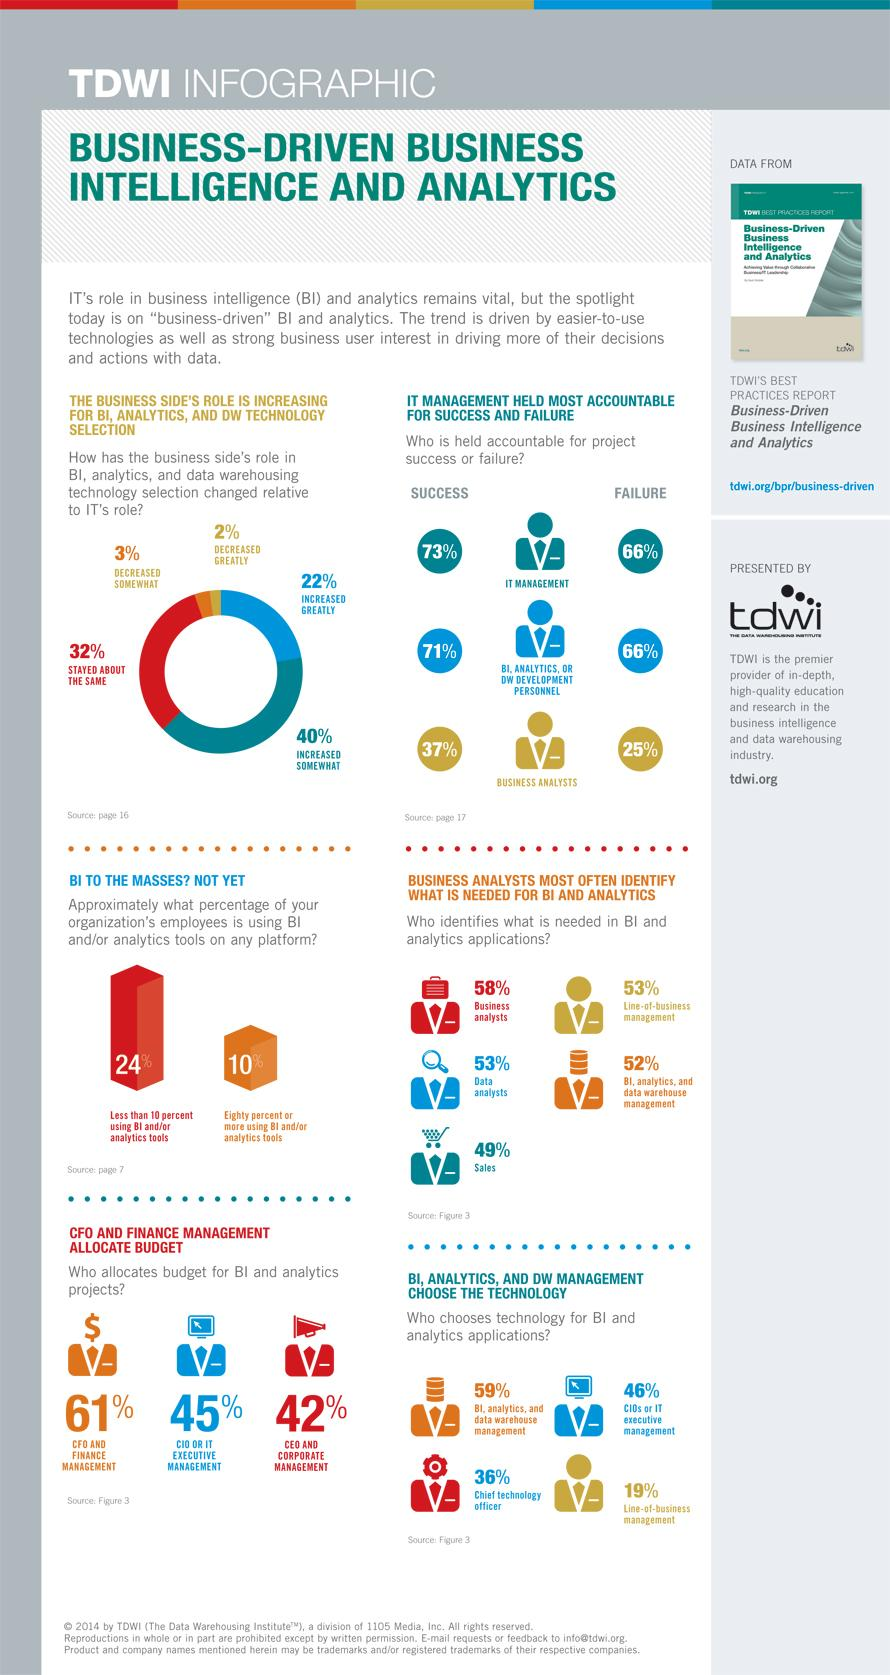List a handful of essential elements in this visual. According to the survey results, only 2% of respondents believe that business has a minimal role in comparison to IT in BI, analytics, and data warehousing. The percentage of DW Management that chooses technology needed in BI and Analytics is 59%. According to the given information, IT management and DW development personnel share a 66% accountability for project failures. According to the provided information, 58% of business analysts identify what is needed in BI. According to the information provided, 61% of Chief Information Officers play a role in allocating budget for Business Intelligence and Analytics. Additionally, 45% of Chief Information Officers also play a role in allocating budget for Business Intelligence and Analytics. The percentage of Chief Information Officers who play a role in allocating budget for Business Intelligence and Analytics is 61% and 45%. 